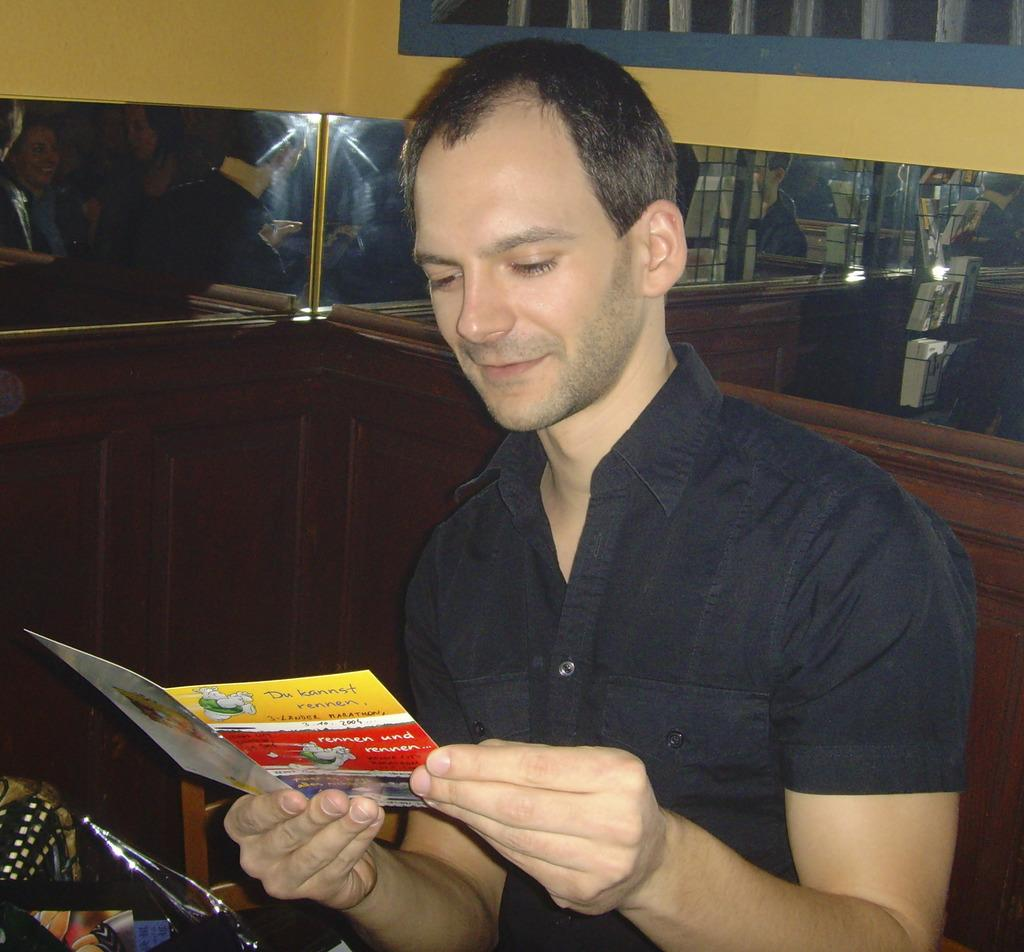Who or what is the main subject in the image? There is a person in the image. What is behind the person in the image? The person is in front of a wall. What is the person wearing in the image? The person is wearing clothes. What is the person holding in the image? The person is holding a card with their hands. What can be seen in the top right corner of the image? There is a window in the top right of the image. What type of property is the person trying to sell in the image? There is no indication in the image that the person is trying to sell any property. 